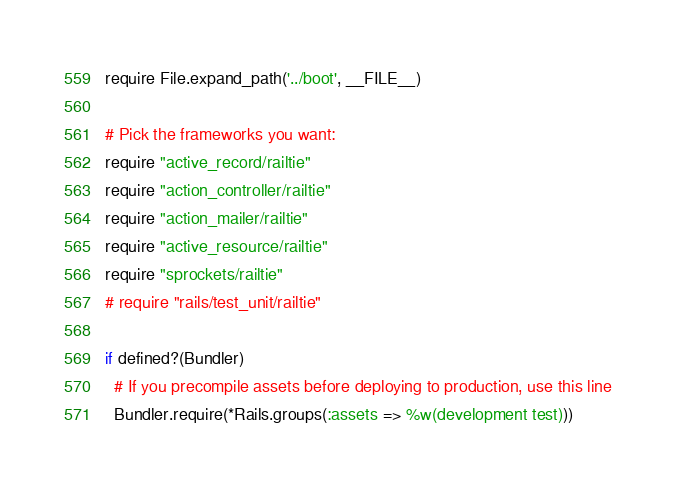Convert code to text. <code><loc_0><loc_0><loc_500><loc_500><_Ruby_>require File.expand_path('../boot', __FILE__)

# Pick the frameworks you want:
require "active_record/railtie"
require "action_controller/railtie"
require "action_mailer/railtie"
require "active_resource/railtie"
require "sprockets/railtie"
# require "rails/test_unit/railtie"

if defined?(Bundler)
  # If you precompile assets before deploying to production, use this line
  Bundler.require(*Rails.groups(:assets => %w(development test)))</code> 